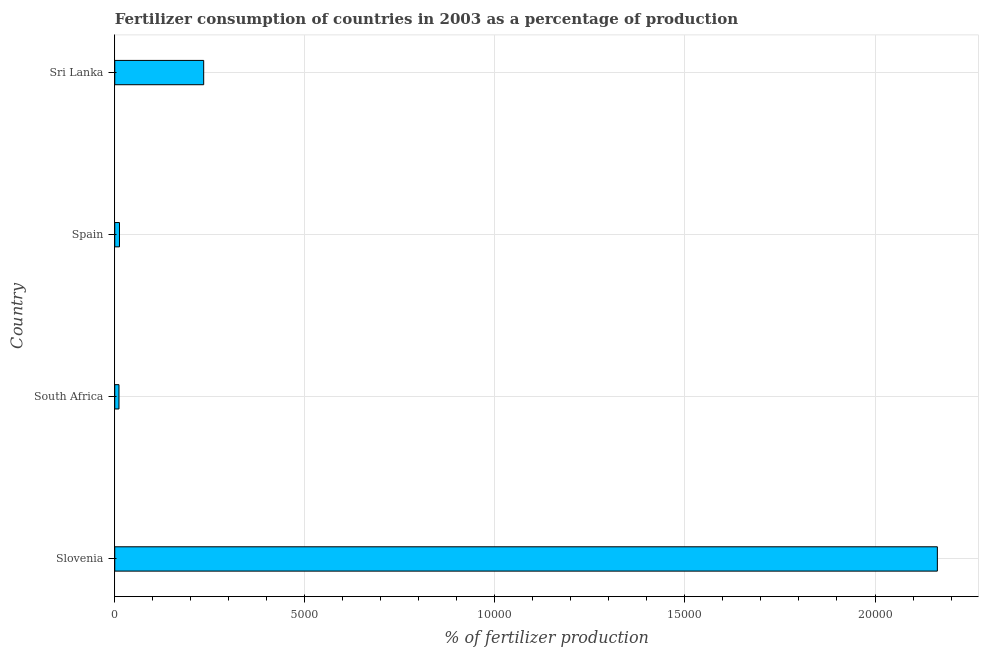Does the graph contain any zero values?
Provide a short and direct response. No. What is the title of the graph?
Your answer should be very brief. Fertilizer consumption of countries in 2003 as a percentage of production. What is the label or title of the X-axis?
Your answer should be very brief. % of fertilizer production. What is the amount of fertilizer consumption in Sri Lanka?
Provide a succinct answer. 2339.65. Across all countries, what is the maximum amount of fertilizer consumption?
Your answer should be compact. 2.16e+04. Across all countries, what is the minimum amount of fertilizer consumption?
Your answer should be compact. 111.28. In which country was the amount of fertilizer consumption maximum?
Provide a succinct answer. Slovenia. In which country was the amount of fertilizer consumption minimum?
Provide a succinct answer. South Africa. What is the sum of the amount of fertilizer consumption?
Offer a very short reply. 2.42e+04. What is the difference between the amount of fertilizer consumption in South Africa and Sri Lanka?
Your answer should be very brief. -2228.38. What is the average amount of fertilizer consumption per country?
Provide a short and direct response. 6054.04. What is the median amount of fertilizer consumption?
Your answer should be very brief. 1232.12. What is the ratio of the amount of fertilizer consumption in Slovenia to that in Spain?
Keep it short and to the point. 173.69. Is the amount of fertilizer consumption in South Africa less than that in Sri Lanka?
Offer a terse response. Yes. Is the difference between the amount of fertilizer consumption in Slovenia and South Africa greater than the difference between any two countries?
Your answer should be compact. Yes. What is the difference between the highest and the second highest amount of fertilizer consumption?
Ensure brevity in your answer.  1.93e+04. Is the sum of the amount of fertilizer consumption in South Africa and Spain greater than the maximum amount of fertilizer consumption across all countries?
Your answer should be very brief. No. What is the difference between the highest and the lowest amount of fertilizer consumption?
Offer a very short reply. 2.15e+04. How many bars are there?
Provide a succinct answer. 4. Are all the bars in the graph horizontal?
Give a very brief answer. Yes. How many countries are there in the graph?
Your answer should be very brief. 4. Are the values on the major ticks of X-axis written in scientific E-notation?
Your answer should be compact. No. What is the % of fertilizer production of Slovenia?
Your answer should be very brief. 2.16e+04. What is the % of fertilizer production in South Africa?
Provide a short and direct response. 111.28. What is the % of fertilizer production in Spain?
Offer a terse response. 124.6. What is the % of fertilizer production in Sri Lanka?
Make the answer very short. 2339.65. What is the difference between the % of fertilizer production in Slovenia and South Africa?
Your answer should be very brief. 2.15e+04. What is the difference between the % of fertilizer production in Slovenia and Spain?
Give a very brief answer. 2.15e+04. What is the difference between the % of fertilizer production in Slovenia and Sri Lanka?
Offer a terse response. 1.93e+04. What is the difference between the % of fertilizer production in South Africa and Spain?
Provide a succinct answer. -13.32. What is the difference between the % of fertilizer production in South Africa and Sri Lanka?
Give a very brief answer. -2228.38. What is the difference between the % of fertilizer production in Spain and Sri Lanka?
Give a very brief answer. -2215.06. What is the ratio of the % of fertilizer production in Slovenia to that in South Africa?
Make the answer very short. 194.48. What is the ratio of the % of fertilizer production in Slovenia to that in Spain?
Ensure brevity in your answer.  173.69. What is the ratio of the % of fertilizer production in Slovenia to that in Sri Lanka?
Your answer should be very brief. 9.25. What is the ratio of the % of fertilizer production in South Africa to that in Spain?
Give a very brief answer. 0.89. What is the ratio of the % of fertilizer production in South Africa to that in Sri Lanka?
Offer a very short reply. 0.05. What is the ratio of the % of fertilizer production in Spain to that in Sri Lanka?
Provide a succinct answer. 0.05. 